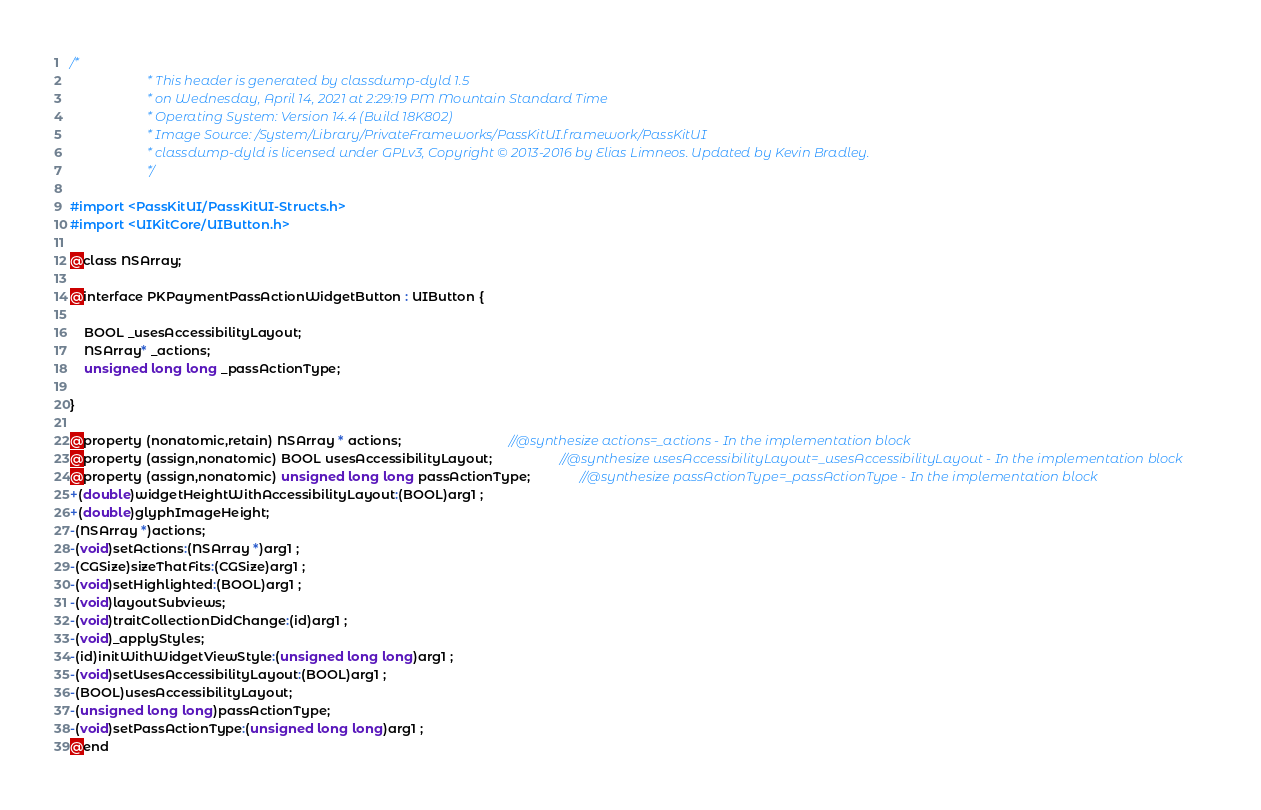<code> <loc_0><loc_0><loc_500><loc_500><_C_>/*
                       * This header is generated by classdump-dyld 1.5
                       * on Wednesday, April 14, 2021 at 2:29:19 PM Mountain Standard Time
                       * Operating System: Version 14.4 (Build 18K802)
                       * Image Source: /System/Library/PrivateFrameworks/PassKitUI.framework/PassKitUI
                       * classdump-dyld is licensed under GPLv3, Copyright © 2013-2016 by Elias Limneos. Updated by Kevin Bradley.
                       */

#import <PassKitUI/PassKitUI-Structs.h>
#import <UIKitCore/UIButton.h>

@class NSArray;

@interface PKPaymentPassActionWidgetButton : UIButton {

	BOOL _usesAccessibilityLayout;
	NSArray* _actions;
	unsigned long long _passActionType;

}

@property (nonatomic,retain) NSArray * actions;                              //@synthesize actions=_actions - In the implementation block
@property (assign,nonatomic) BOOL usesAccessibilityLayout;                   //@synthesize usesAccessibilityLayout=_usesAccessibilityLayout - In the implementation block
@property (assign,nonatomic) unsigned long long passActionType;              //@synthesize passActionType=_passActionType - In the implementation block
+(double)widgetHeightWithAccessibilityLayout:(BOOL)arg1 ;
+(double)glyphImageHeight;
-(NSArray *)actions;
-(void)setActions:(NSArray *)arg1 ;
-(CGSize)sizeThatFits:(CGSize)arg1 ;
-(void)setHighlighted:(BOOL)arg1 ;
-(void)layoutSubviews;
-(void)traitCollectionDidChange:(id)arg1 ;
-(void)_applyStyles;
-(id)initWithWidgetViewStyle:(unsigned long long)arg1 ;
-(void)setUsesAccessibilityLayout:(BOOL)arg1 ;
-(BOOL)usesAccessibilityLayout;
-(unsigned long long)passActionType;
-(void)setPassActionType:(unsigned long long)arg1 ;
@end

</code> 